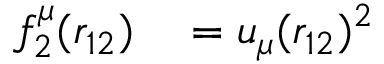Convert formula to latex. <formula><loc_0><loc_0><loc_500><loc_500>\begin{array} { r l } { f _ { 2 } ^ { \mu } ( r _ { 1 2 } ) } & = u _ { \mu } ( r _ { 1 2 } ) ^ { 2 } } \end{array}</formula> 